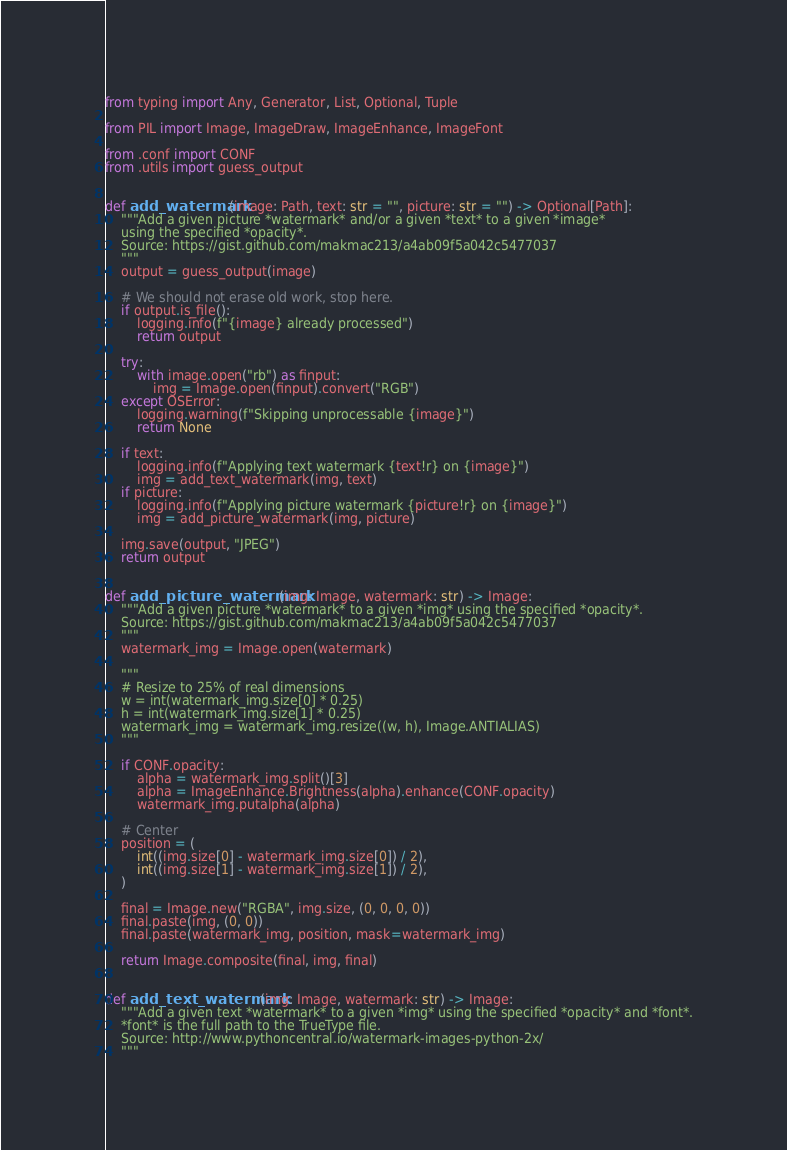<code> <loc_0><loc_0><loc_500><loc_500><_Python_>from typing import Any, Generator, List, Optional, Tuple

from PIL import Image, ImageDraw, ImageEnhance, ImageFont

from .conf import CONF
from .utils import guess_output


def add_watermark(image: Path, text: str = "", picture: str = "") -> Optional[Path]:
    """Add a given picture *watermark* and/or a given *text* to a given *image*
    using the specified *opacity*.
    Source: https://gist.github.com/makmac213/a4ab09f5a042c5477037
    """
    output = guess_output(image)

    # We should not erase old work, stop here.
    if output.is_file():
        logging.info(f"{image} already processed")
        return output

    try:
        with image.open("rb") as finput:
            img = Image.open(finput).convert("RGB")
    except OSError:
        logging.warning(f"Skipping unprocessable {image}")
        return None

    if text:
        logging.info(f"Applying text watermark {text!r} on {image}")
        img = add_text_watermark(img, text)
    if picture:
        logging.info(f"Applying picture watermark {picture!r} on {image}")
        img = add_picture_watermark(img, picture)

    img.save(output, "JPEG")
    return output


def add_picture_watermark(img: Image, watermark: str) -> Image:
    """Add a given picture *watermark* to a given *img* using the specified *opacity*.
    Source: https://gist.github.com/makmac213/a4ab09f5a042c5477037
    """
    watermark_img = Image.open(watermark)

    """
    # Resize to 25% of real dimensions
    w = int(watermark_img.size[0] * 0.25)
    h = int(watermark_img.size[1] * 0.25)
    watermark_img = watermark_img.resize((w, h), Image.ANTIALIAS)
    """

    if CONF.opacity:
        alpha = watermark_img.split()[3]
        alpha = ImageEnhance.Brightness(alpha).enhance(CONF.opacity)
        watermark_img.putalpha(alpha)

    # Center
    position = (
        int((img.size[0] - watermark_img.size[0]) / 2),
        int((img.size[1] - watermark_img.size[1]) / 2),
    )

    final = Image.new("RGBA", img.size, (0, 0, 0, 0))
    final.paste(img, (0, 0))
    final.paste(watermark_img, position, mask=watermark_img)

    return Image.composite(final, img, final)


def add_text_watermark(img: Image, watermark: str) -> Image:
    """Add a given text *watermark* to a given *img* using the specified *opacity* and *font*.
    *font* is the full path to the TrueType file.
    Source: http://www.pythoncentral.io/watermark-images-python-2x/
    """</code> 